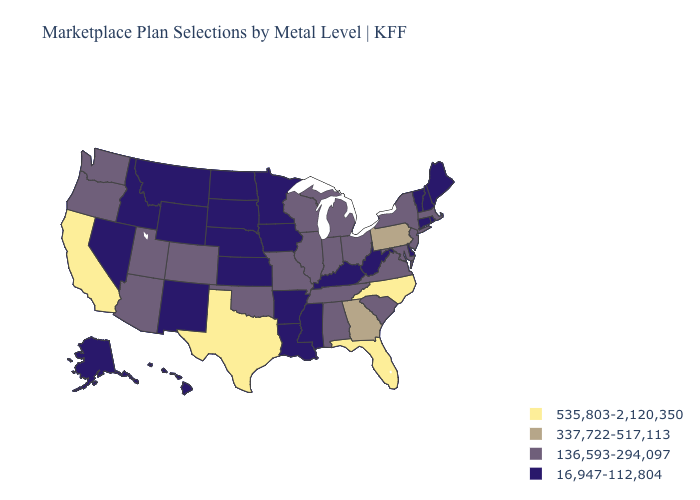Name the states that have a value in the range 337,722-517,113?
Answer briefly. Georgia, Pennsylvania. What is the value of Connecticut?
Give a very brief answer. 16,947-112,804. What is the highest value in states that border Louisiana?
Give a very brief answer. 535,803-2,120,350. What is the value of Indiana?
Give a very brief answer. 136,593-294,097. What is the highest value in states that border Rhode Island?
Concise answer only. 136,593-294,097. What is the value of New York?
Answer briefly. 136,593-294,097. Does the first symbol in the legend represent the smallest category?
Answer briefly. No. Name the states that have a value in the range 337,722-517,113?
Keep it brief. Georgia, Pennsylvania. Name the states that have a value in the range 16,947-112,804?
Quick response, please. Alaska, Arkansas, Connecticut, Delaware, Hawaii, Idaho, Iowa, Kansas, Kentucky, Louisiana, Maine, Minnesota, Mississippi, Montana, Nebraska, Nevada, New Hampshire, New Mexico, North Dakota, Rhode Island, South Dakota, Vermont, West Virginia, Wyoming. Name the states that have a value in the range 16,947-112,804?
Quick response, please. Alaska, Arkansas, Connecticut, Delaware, Hawaii, Idaho, Iowa, Kansas, Kentucky, Louisiana, Maine, Minnesota, Mississippi, Montana, Nebraska, Nevada, New Hampshire, New Mexico, North Dakota, Rhode Island, South Dakota, Vermont, West Virginia, Wyoming. Name the states that have a value in the range 337,722-517,113?
Be succinct. Georgia, Pennsylvania. What is the value of Rhode Island?
Answer briefly. 16,947-112,804. How many symbols are there in the legend?
Give a very brief answer. 4. Name the states that have a value in the range 136,593-294,097?
Short answer required. Alabama, Arizona, Colorado, Illinois, Indiana, Maryland, Massachusetts, Michigan, Missouri, New Jersey, New York, Ohio, Oklahoma, Oregon, South Carolina, Tennessee, Utah, Virginia, Washington, Wisconsin. 